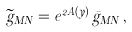Convert formula to latex. <formula><loc_0><loc_0><loc_500><loc_500>\widetilde { g } _ { M N } = e ^ { 2 A ( y ) } \, \bar { g } _ { M N } \, ,</formula> 